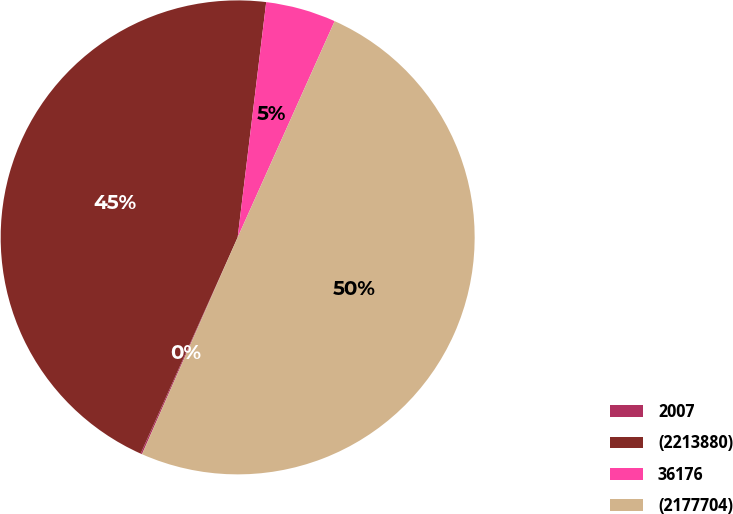Convert chart to OTSL. <chart><loc_0><loc_0><loc_500><loc_500><pie_chart><fcel>2007<fcel>(2213880)<fcel>36176<fcel>(2177704)<nl><fcel>0.1%<fcel>45.21%<fcel>4.79%<fcel>49.9%<nl></chart> 